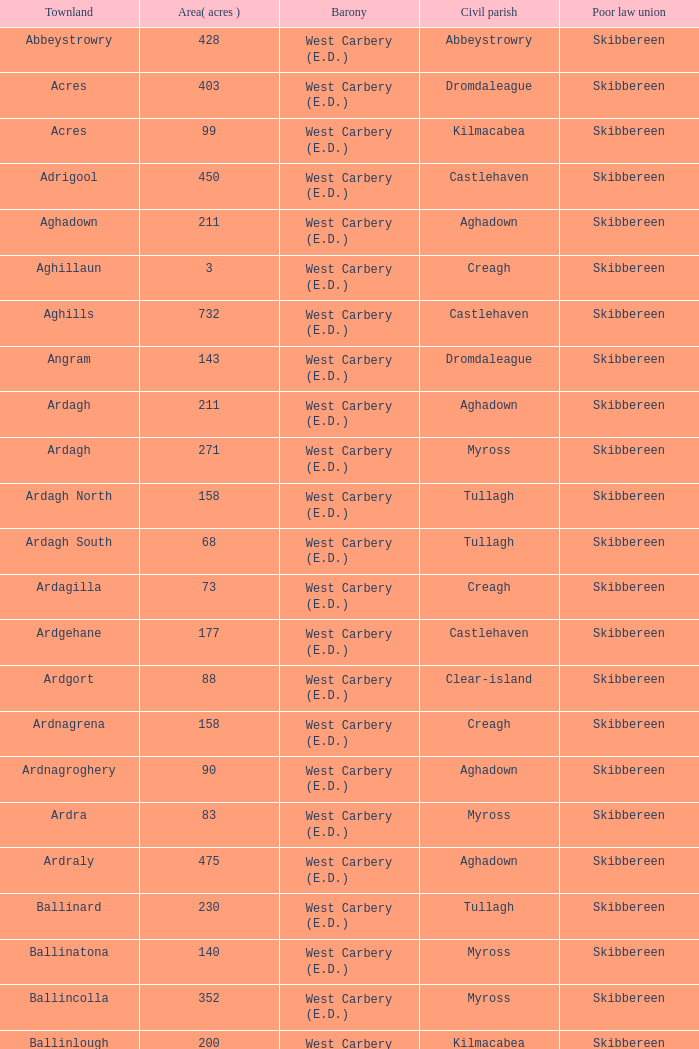What are the areas (in acres) of the Kilnahera East townland? 257.0. 